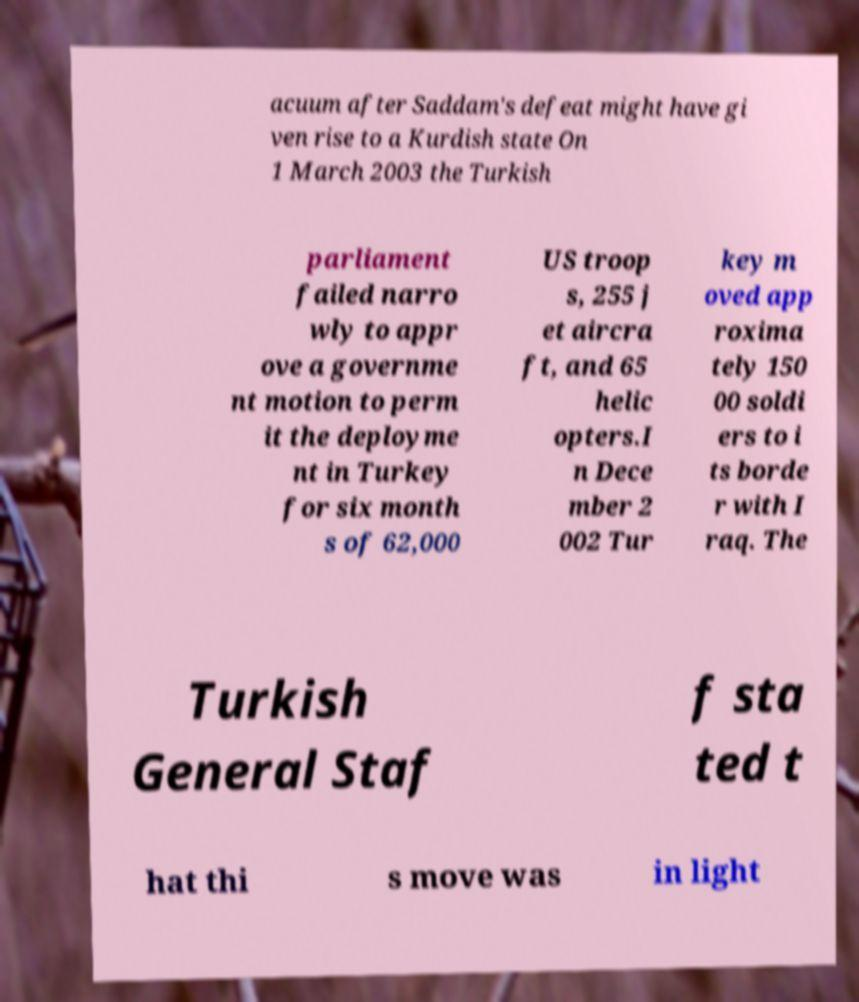Please identify and transcribe the text found in this image. acuum after Saddam's defeat might have gi ven rise to a Kurdish state On 1 March 2003 the Turkish parliament failed narro wly to appr ove a governme nt motion to perm it the deployme nt in Turkey for six month s of 62,000 US troop s, 255 j et aircra ft, and 65 helic opters.I n Dece mber 2 002 Tur key m oved app roxima tely 150 00 soldi ers to i ts borde r with I raq. The Turkish General Staf f sta ted t hat thi s move was in light 